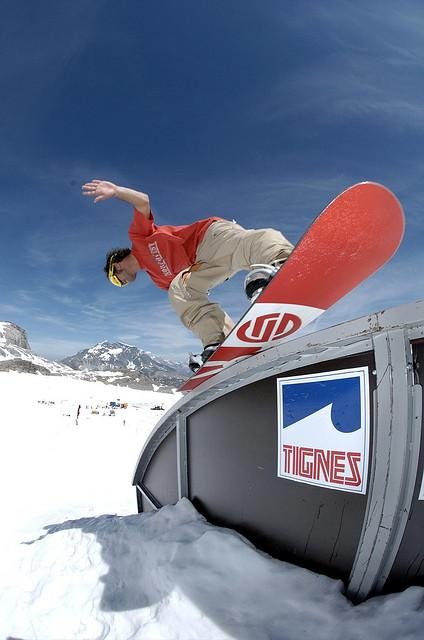What is this type of snowboard trick called? Please explain your reasoning. grinding. The trick is grinding. 